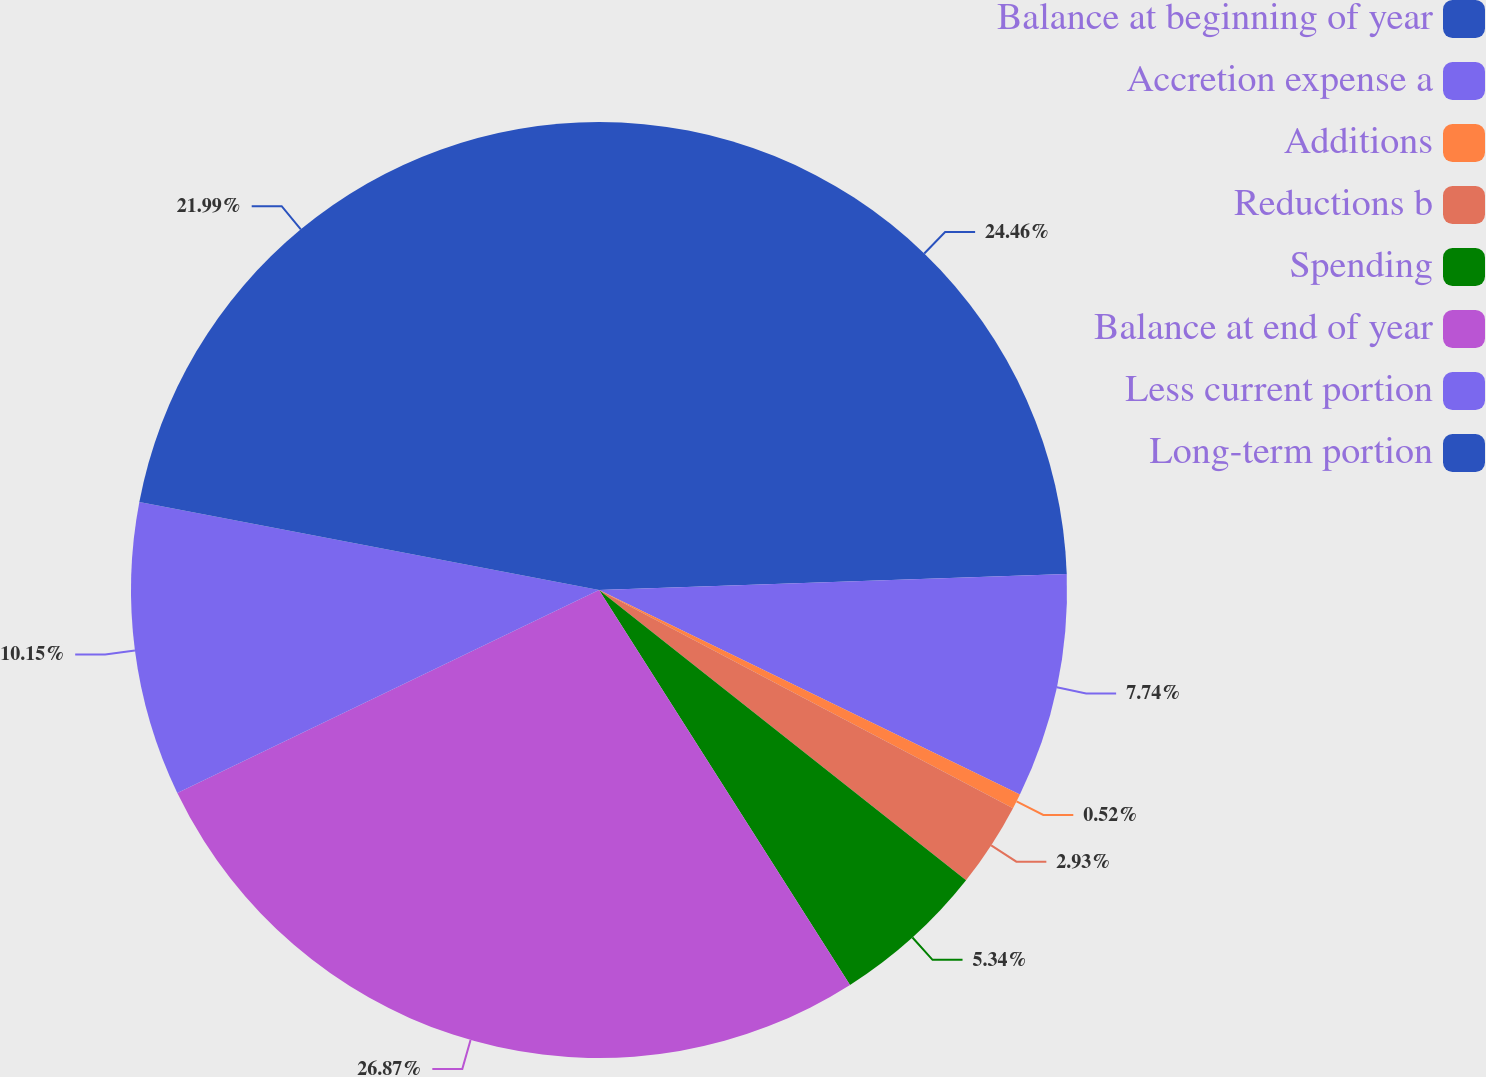Convert chart. <chart><loc_0><loc_0><loc_500><loc_500><pie_chart><fcel>Balance at beginning of year<fcel>Accretion expense a<fcel>Additions<fcel>Reductions b<fcel>Spending<fcel>Balance at end of year<fcel>Less current portion<fcel>Long-term portion<nl><fcel>24.46%<fcel>7.74%<fcel>0.52%<fcel>2.93%<fcel>5.34%<fcel>26.87%<fcel>10.15%<fcel>21.99%<nl></chart> 